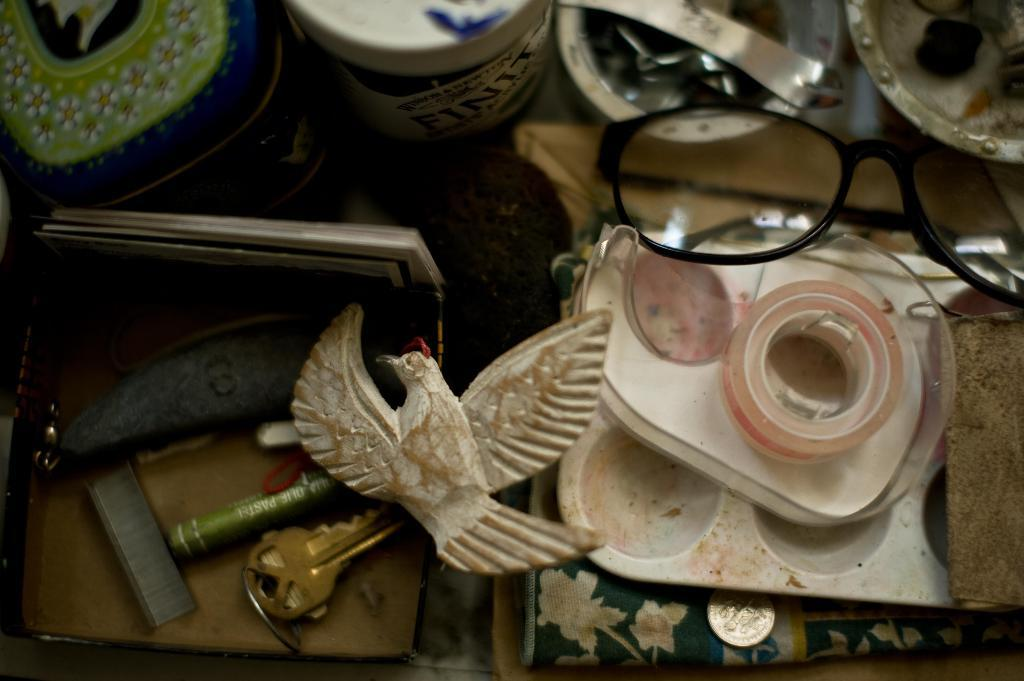What type of accessory is present in the image? There are spectacles in the image. What objects are present in the image that might be used for storage or organization? There are boxes in the image. What type of fastener is present in the image? There are staples in the image. What object is present in the image that might be used for unlocking or securing? There is a key in the image. What material is present in the image that might be used for repairing or filling gaps? There is plaster in the image. What type of produce is being exchanged in the image? There is no produce or exchange of goods depicted in the image. What type of loaf is being prepared in the image? There is no loaf or baking activity depicted in the image. 